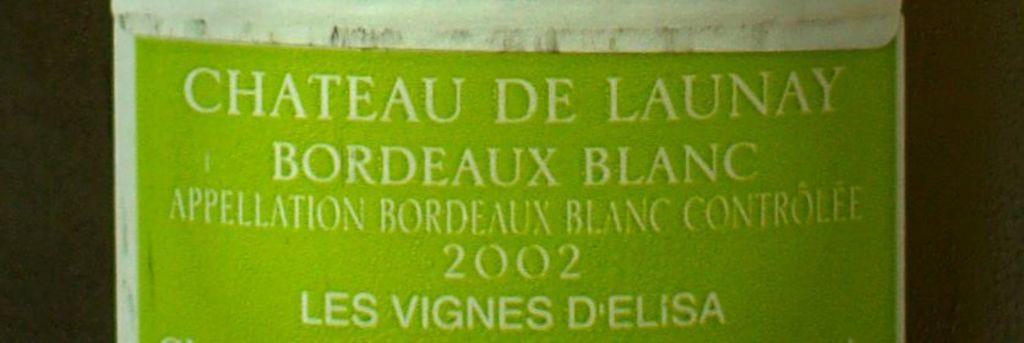<image>
Offer a succinct explanation of the picture presented. A close up of a bottle o wine that is called Chateau De Launay. 